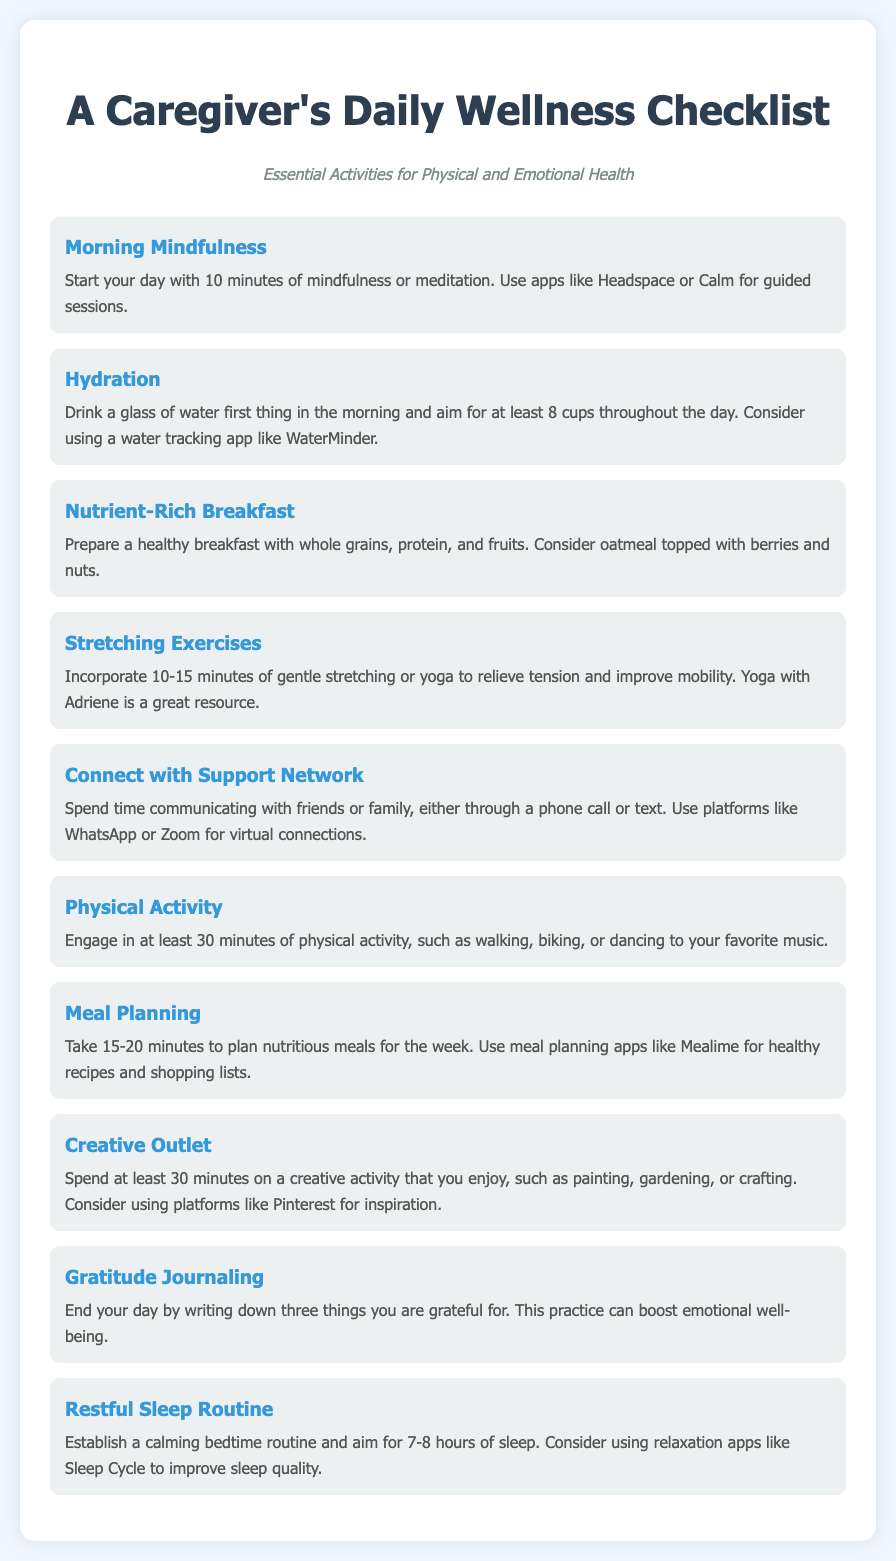What is the title of the document? The title is presented prominently at the top of the document.
Answer: A Caregiver's Daily Wellness Checklist How many minutes of mindfulness are suggested in the morning? The checklist specifies 10 minutes of mindfulness or meditation in the morning.
Answer: 10 minutes What activity is recommended for hydration? The checklist advises drinking a glass of water first thing in the morning and throughout the day.
Answer: Drink a glass of water Which app is mentioned for guided mindfulness sessions? The document suggests using mindfulness apps for guidance, specifically naming one.
Answer: Headspace What is the recommended duration for physical activity? The checklist suggests engaging in physical activity for at least 30 minutes.
Answer: 30 minutes What type of breakfast is suggested? The checklist recommends a healthy breakfast consisting of specific food groups.
Answer: Nutrient-Rich Breakfast What is an example of a creative outlet mentioned? The document lists various activities for creativity, indicating at least one.
Answer: Painting How should one end their day according to the checklist? The checklist suggests a specific journaling activity for closing the day positively.
Answer: Gratitude Journaling What is the suggested bedtime sleep duration? The document specifies an ideal amount of sleep for caregivers.
Answer: 7-8 hours 